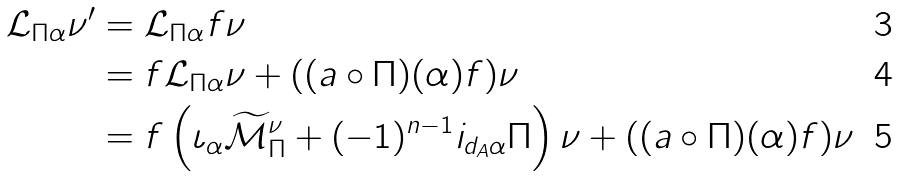<formula> <loc_0><loc_0><loc_500><loc_500>\mathcal { L } _ { \Pi \alpha } \nu ^ { \prime } & = \mathcal { L } _ { \Pi \alpha } f \nu \\ & = f \mathcal { L } _ { \Pi \alpha } \nu + ( ( a \circ \Pi ) ( \alpha ) f ) \nu \\ & = f \left ( \iota _ { \alpha } \widetilde { \mathcal { M } } _ { \Pi } ^ { \nu } + ( - 1 ) ^ { n - 1 } i _ { d _ { A } \alpha } \Pi \right ) \nu + ( ( a \circ \Pi ) ( \alpha ) f ) \nu</formula> 